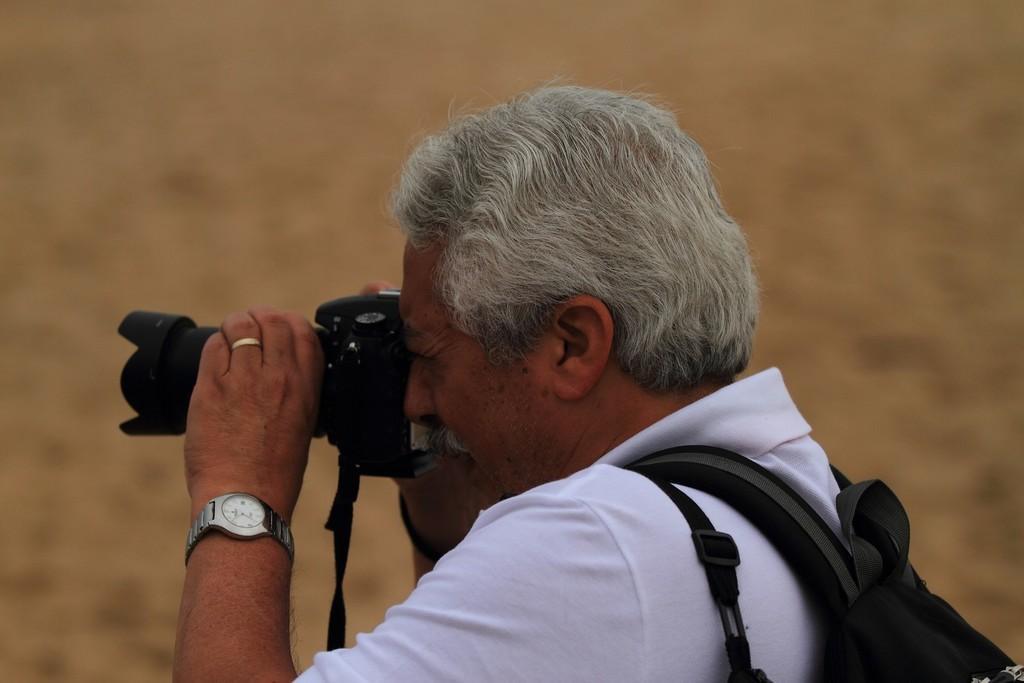Please provide a concise description of this image. In this image we can see a man is holding a camera in his hands and clicking the pictures. 